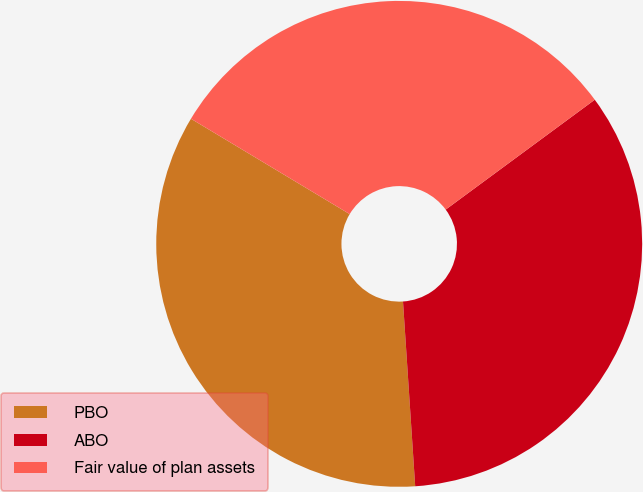Convert chart. <chart><loc_0><loc_0><loc_500><loc_500><pie_chart><fcel>PBO<fcel>ABO<fcel>Fair value of plan assets<nl><fcel>34.66%<fcel>34.06%<fcel>31.28%<nl></chart> 